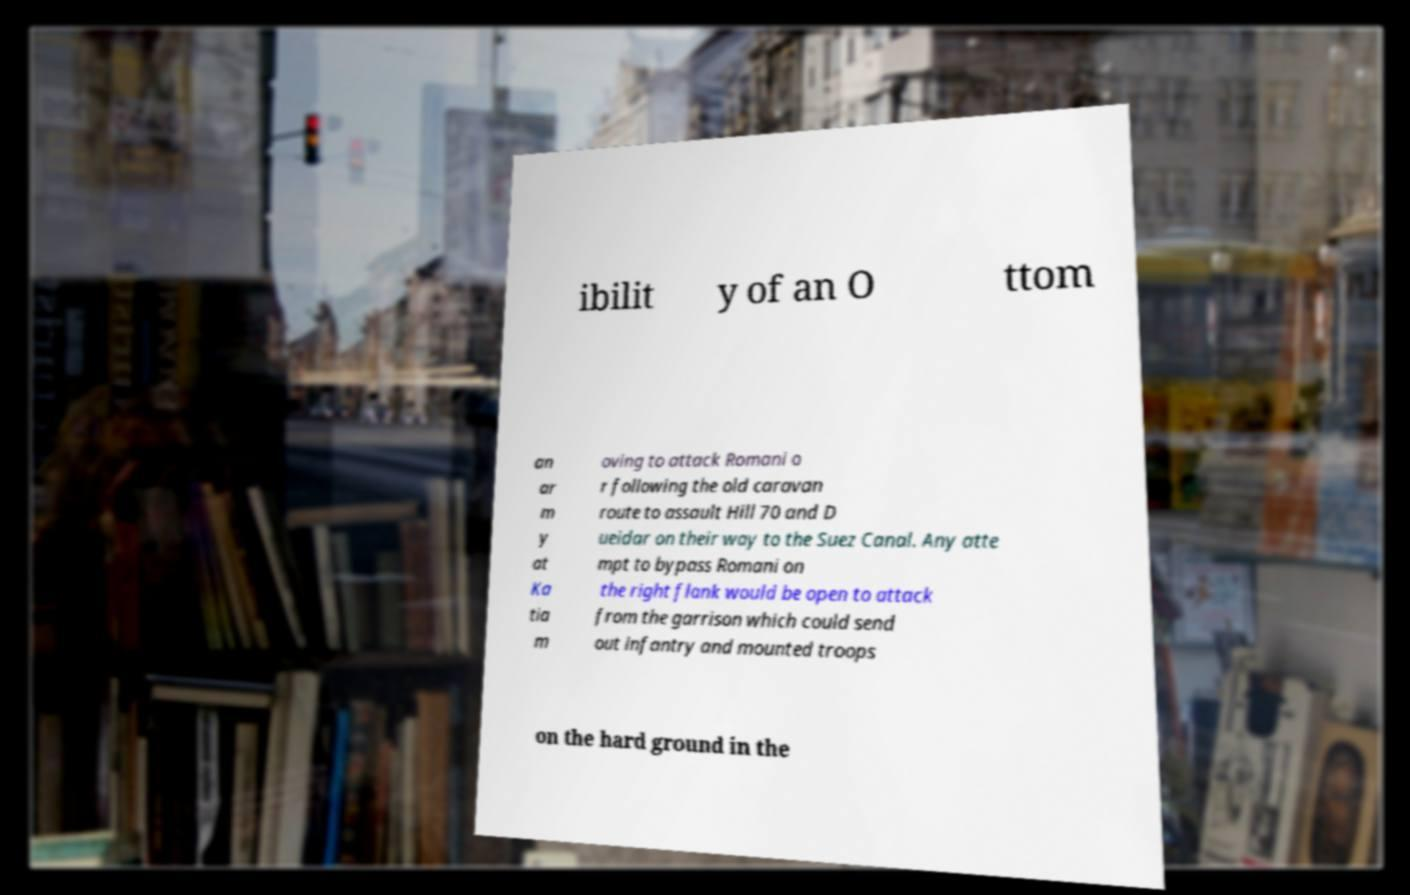I need the written content from this picture converted into text. Can you do that? ibilit y of an O ttom an ar m y at Ka tia m oving to attack Romani o r following the old caravan route to assault Hill 70 and D ueidar on their way to the Suez Canal. Any atte mpt to bypass Romani on the right flank would be open to attack from the garrison which could send out infantry and mounted troops on the hard ground in the 